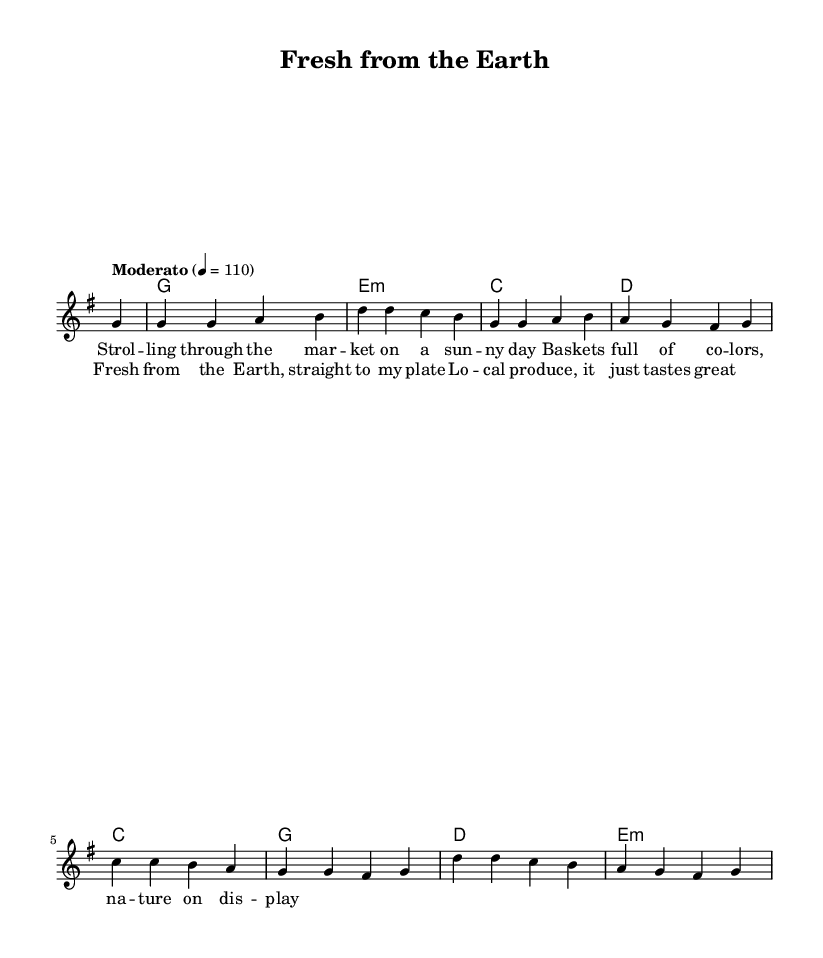What is the key signature of this music? The key signature is G major, which has one sharp (F#). This can be identified by looking at the key signature located at the beginning of the staff, which indicates the musical key.
Answer: G major What is the time signature of this piece? The time signature is 4/4, which is indicated at the beginning of the sheet music. It is determined by the two numbers: the top number indicates there are four beats in each measure, and the bottom number indicates a quarter note receives one beat.
Answer: 4/4 What is the tempo marking for the piece? The tempo marking is "Moderato" with a metronome marking of 110. This indicates a moderate pace of the music, and the number signifies the beats per minute.
Answer: Moderato, 110 How many measures are there in the melody? There are 8 measures in the melody. This can be counted by looking at the vertical bar lines that divide the music into measures.
Answer: 8 Which chord is played in the second measure? The chord played in the second measure is E minor. This is determined by looking at the chord symbols above the staff, where the E minor chord is labeled in that position.
Answer: E minor What is the main theme of the lyrics? The main theme of the lyrics is about enjoying local produce at a farmer's market. This understanding comes from the words presented in the lyric mode, which emphasize a joyful experience with nature and fresh food.
Answer: Local produce In which section are the lyrics for the chorus located? The lyrics for the chorus are located after the verse section. This arrangement can be seen by the distinct labeling of "verse" and "chorus" in the lyrics section, indicating where each part begins.
Answer: Chorus 